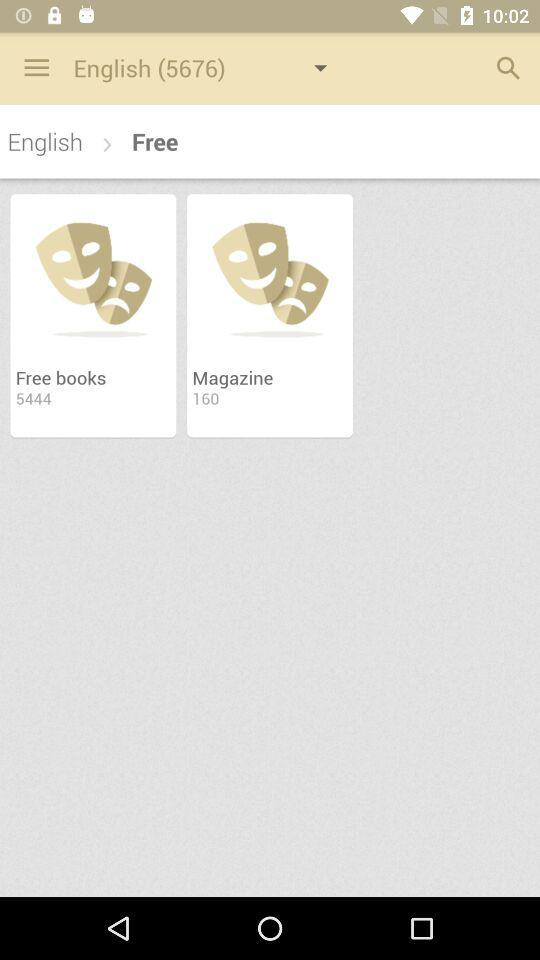How many more books are there than magazines?
Answer the question using a single word or phrase. 5284 